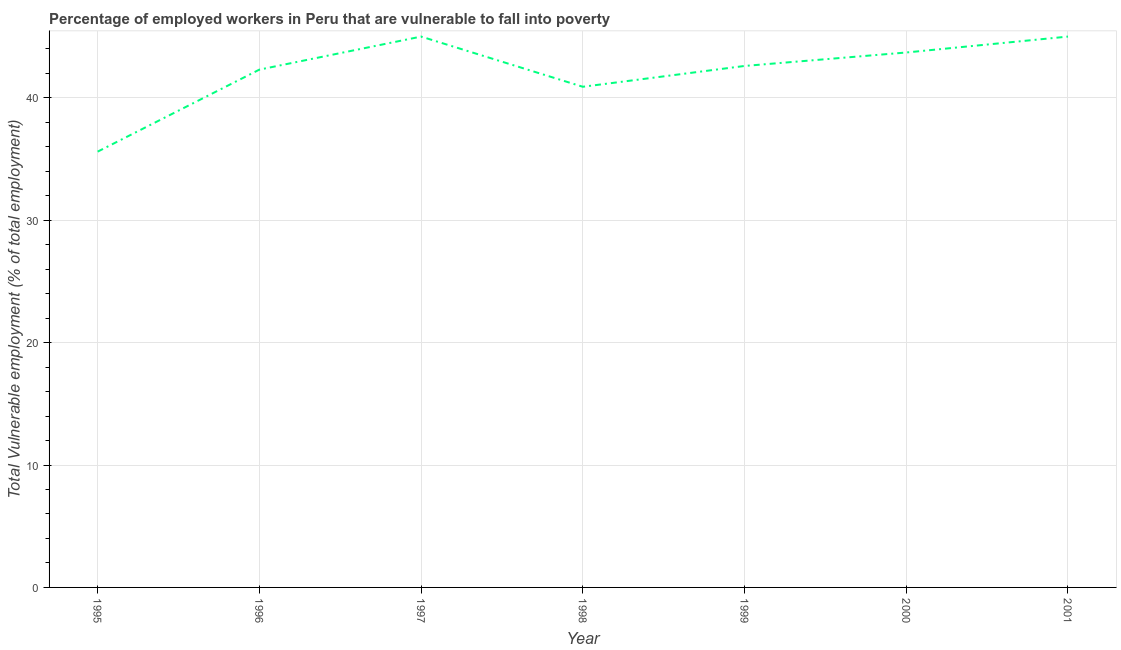What is the total vulnerable employment in 2000?
Keep it short and to the point. 43.7. Across all years, what is the maximum total vulnerable employment?
Offer a terse response. 45. Across all years, what is the minimum total vulnerable employment?
Make the answer very short. 35.6. What is the sum of the total vulnerable employment?
Make the answer very short. 295.1. What is the difference between the total vulnerable employment in 1997 and 1999?
Make the answer very short. 2.4. What is the average total vulnerable employment per year?
Keep it short and to the point. 42.16. What is the median total vulnerable employment?
Make the answer very short. 42.6. What is the ratio of the total vulnerable employment in 1997 to that in 2000?
Your answer should be compact. 1.03. Is the difference between the total vulnerable employment in 1996 and 1998 greater than the difference between any two years?
Give a very brief answer. No. What is the difference between the highest and the lowest total vulnerable employment?
Ensure brevity in your answer.  9.4. In how many years, is the total vulnerable employment greater than the average total vulnerable employment taken over all years?
Provide a succinct answer. 5. How many lines are there?
Provide a short and direct response. 1. What is the difference between two consecutive major ticks on the Y-axis?
Your answer should be very brief. 10. Are the values on the major ticks of Y-axis written in scientific E-notation?
Make the answer very short. No. Does the graph contain grids?
Keep it short and to the point. Yes. What is the title of the graph?
Ensure brevity in your answer.  Percentage of employed workers in Peru that are vulnerable to fall into poverty. What is the label or title of the X-axis?
Give a very brief answer. Year. What is the label or title of the Y-axis?
Keep it short and to the point. Total Vulnerable employment (% of total employment). What is the Total Vulnerable employment (% of total employment) of 1995?
Ensure brevity in your answer.  35.6. What is the Total Vulnerable employment (% of total employment) in 1996?
Offer a terse response. 42.3. What is the Total Vulnerable employment (% of total employment) of 1997?
Ensure brevity in your answer.  45. What is the Total Vulnerable employment (% of total employment) in 1998?
Offer a very short reply. 40.9. What is the Total Vulnerable employment (% of total employment) in 1999?
Offer a terse response. 42.6. What is the Total Vulnerable employment (% of total employment) in 2000?
Offer a terse response. 43.7. What is the Total Vulnerable employment (% of total employment) in 2001?
Make the answer very short. 45. What is the difference between the Total Vulnerable employment (% of total employment) in 1995 and 1998?
Your answer should be compact. -5.3. What is the difference between the Total Vulnerable employment (% of total employment) in 1995 and 1999?
Your answer should be very brief. -7. What is the difference between the Total Vulnerable employment (% of total employment) in 1995 and 2000?
Provide a succinct answer. -8.1. What is the difference between the Total Vulnerable employment (% of total employment) in 1996 and 1997?
Provide a short and direct response. -2.7. What is the difference between the Total Vulnerable employment (% of total employment) in 1996 and 1998?
Provide a succinct answer. 1.4. What is the difference between the Total Vulnerable employment (% of total employment) in 1996 and 2000?
Your answer should be very brief. -1.4. What is the difference between the Total Vulnerable employment (% of total employment) in 1997 and 2001?
Ensure brevity in your answer.  0. What is the difference between the Total Vulnerable employment (% of total employment) in 1998 and 1999?
Ensure brevity in your answer.  -1.7. What is the difference between the Total Vulnerable employment (% of total employment) in 1998 and 2000?
Offer a terse response. -2.8. What is the difference between the Total Vulnerable employment (% of total employment) in 1998 and 2001?
Your answer should be compact. -4.1. What is the difference between the Total Vulnerable employment (% of total employment) in 1999 and 2000?
Offer a terse response. -1.1. What is the ratio of the Total Vulnerable employment (% of total employment) in 1995 to that in 1996?
Give a very brief answer. 0.84. What is the ratio of the Total Vulnerable employment (% of total employment) in 1995 to that in 1997?
Offer a very short reply. 0.79. What is the ratio of the Total Vulnerable employment (% of total employment) in 1995 to that in 1998?
Provide a short and direct response. 0.87. What is the ratio of the Total Vulnerable employment (% of total employment) in 1995 to that in 1999?
Your answer should be very brief. 0.84. What is the ratio of the Total Vulnerable employment (% of total employment) in 1995 to that in 2000?
Make the answer very short. 0.81. What is the ratio of the Total Vulnerable employment (% of total employment) in 1995 to that in 2001?
Ensure brevity in your answer.  0.79. What is the ratio of the Total Vulnerable employment (% of total employment) in 1996 to that in 1998?
Offer a terse response. 1.03. What is the ratio of the Total Vulnerable employment (% of total employment) in 1997 to that in 1999?
Your response must be concise. 1.06. What is the ratio of the Total Vulnerable employment (% of total employment) in 1998 to that in 2000?
Provide a short and direct response. 0.94. What is the ratio of the Total Vulnerable employment (% of total employment) in 1998 to that in 2001?
Give a very brief answer. 0.91. What is the ratio of the Total Vulnerable employment (% of total employment) in 1999 to that in 2000?
Give a very brief answer. 0.97. What is the ratio of the Total Vulnerable employment (% of total employment) in 1999 to that in 2001?
Offer a terse response. 0.95. 